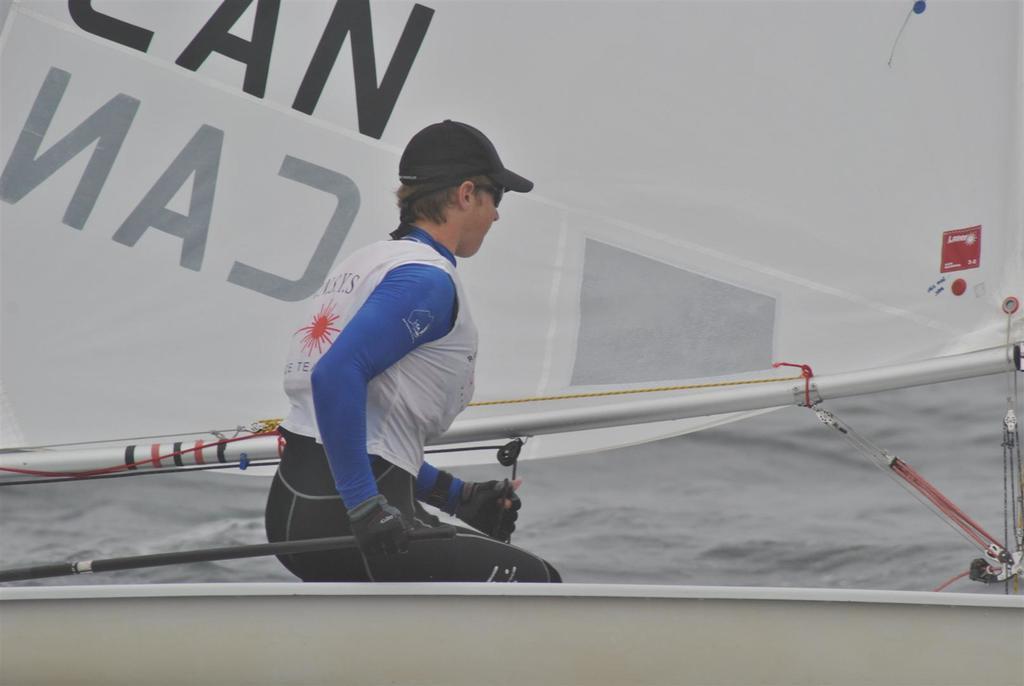Could you give a brief overview of what you see in this image? In the image there is a woman sitting on a boat, behind her there is a mast and behind the boat there is a water surface. 